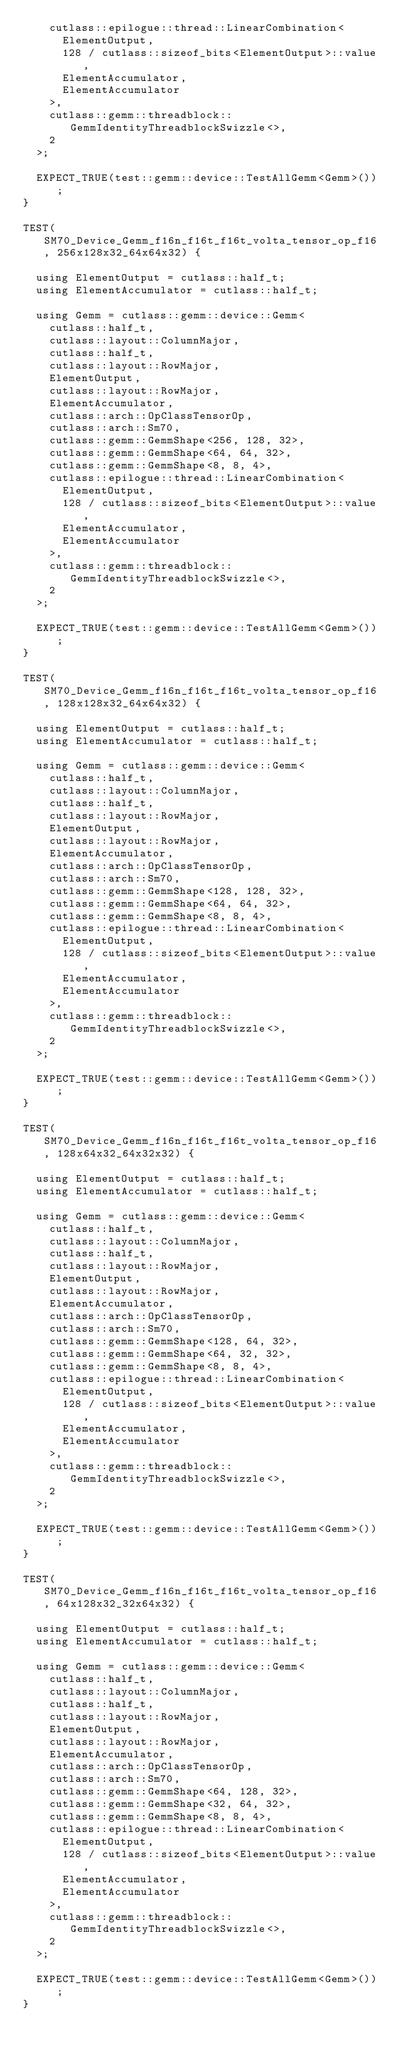<code> <loc_0><loc_0><loc_500><loc_500><_Cuda_>    cutlass::epilogue::thread::LinearCombination<
      ElementOutput,
      128 / cutlass::sizeof_bits<ElementOutput>::value,
      ElementAccumulator,
      ElementAccumulator
    >,
    cutlass::gemm::threadblock::GemmIdentityThreadblockSwizzle<>,
    2
  >;
  
  EXPECT_TRUE(test::gemm::device::TestAllGemm<Gemm>());
}

TEST(SM70_Device_Gemm_f16n_f16t_f16t_volta_tensor_op_f16, 256x128x32_64x64x32) {

  using ElementOutput = cutlass::half_t;
  using ElementAccumulator = cutlass::half_t;

  using Gemm = cutlass::gemm::device::Gemm<
    cutlass::half_t,
    cutlass::layout::ColumnMajor,
    cutlass::half_t,
    cutlass::layout::RowMajor,
    ElementOutput,
    cutlass::layout::RowMajor,
    ElementAccumulator,
    cutlass::arch::OpClassTensorOp,
    cutlass::arch::Sm70,
    cutlass::gemm::GemmShape<256, 128, 32>,
    cutlass::gemm::GemmShape<64, 64, 32>,
    cutlass::gemm::GemmShape<8, 8, 4>,
    cutlass::epilogue::thread::LinearCombination<
      ElementOutput,
      128 / cutlass::sizeof_bits<ElementOutput>::value,
      ElementAccumulator,
      ElementAccumulator
    >,
    cutlass::gemm::threadblock::GemmIdentityThreadblockSwizzle<>,
    2
  >;

  EXPECT_TRUE(test::gemm::device::TestAllGemm<Gemm>());
}

TEST(SM70_Device_Gemm_f16n_f16t_f16t_volta_tensor_op_f16, 128x128x32_64x64x32) {

  using ElementOutput = cutlass::half_t;
  using ElementAccumulator = cutlass::half_t;

  using Gemm = cutlass::gemm::device::Gemm<
    cutlass::half_t,
    cutlass::layout::ColumnMajor,
    cutlass::half_t,
    cutlass::layout::RowMajor,
    ElementOutput,
    cutlass::layout::RowMajor,
    ElementAccumulator,
    cutlass::arch::OpClassTensorOp,
    cutlass::arch::Sm70,
    cutlass::gemm::GemmShape<128, 128, 32>,
    cutlass::gemm::GemmShape<64, 64, 32>,
    cutlass::gemm::GemmShape<8, 8, 4>,
    cutlass::epilogue::thread::LinearCombination<
      ElementOutput,
      128 / cutlass::sizeof_bits<ElementOutput>::value,
      ElementAccumulator,
      ElementAccumulator
    >,
    cutlass::gemm::threadblock::GemmIdentityThreadblockSwizzle<>,
    2
  >;

  EXPECT_TRUE(test::gemm::device::TestAllGemm<Gemm>());
}

TEST(SM70_Device_Gemm_f16n_f16t_f16t_volta_tensor_op_f16, 128x64x32_64x32x32) {

  using ElementOutput = cutlass::half_t;
  using ElementAccumulator = cutlass::half_t;

  using Gemm = cutlass::gemm::device::Gemm<
    cutlass::half_t,
    cutlass::layout::ColumnMajor,
    cutlass::half_t,
    cutlass::layout::RowMajor,
    ElementOutput,
    cutlass::layout::RowMajor,
    ElementAccumulator,
    cutlass::arch::OpClassTensorOp,
    cutlass::arch::Sm70,
    cutlass::gemm::GemmShape<128, 64, 32>,
    cutlass::gemm::GemmShape<64, 32, 32>,
    cutlass::gemm::GemmShape<8, 8, 4>,
    cutlass::epilogue::thread::LinearCombination<
      ElementOutput,
      128 / cutlass::sizeof_bits<ElementOutput>::value,
      ElementAccumulator,
      ElementAccumulator
    >,
    cutlass::gemm::threadblock::GemmIdentityThreadblockSwizzle<>,
    2
  >;

  EXPECT_TRUE(test::gemm::device::TestAllGemm<Gemm>());
}

TEST(SM70_Device_Gemm_f16n_f16t_f16t_volta_tensor_op_f16, 64x128x32_32x64x32) {

  using ElementOutput = cutlass::half_t;
  using ElementAccumulator = cutlass::half_t;

  using Gemm = cutlass::gemm::device::Gemm<
    cutlass::half_t,
    cutlass::layout::ColumnMajor,
    cutlass::half_t,
    cutlass::layout::RowMajor,
    ElementOutput,
    cutlass::layout::RowMajor,
    ElementAccumulator,
    cutlass::arch::OpClassTensorOp,
    cutlass::arch::Sm70,
    cutlass::gemm::GemmShape<64, 128, 32>,
    cutlass::gemm::GemmShape<32, 64, 32>,
    cutlass::gemm::GemmShape<8, 8, 4>,
    cutlass::epilogue::thread::LinearCombination<
      ElementOutput,
      128 / cutlass::sizeof_bits<ElementOutput>::value,
      ElementAccumulator,
      ElementAccumulator
    >,
    cutlass::gemm::threadblock::GemmIdentityThreadblockSwizzle<>,
    2
  >;

  EXPECT_TRUE(test::gemm::device::TestAllGemm<Gemm>());
}
</code> 